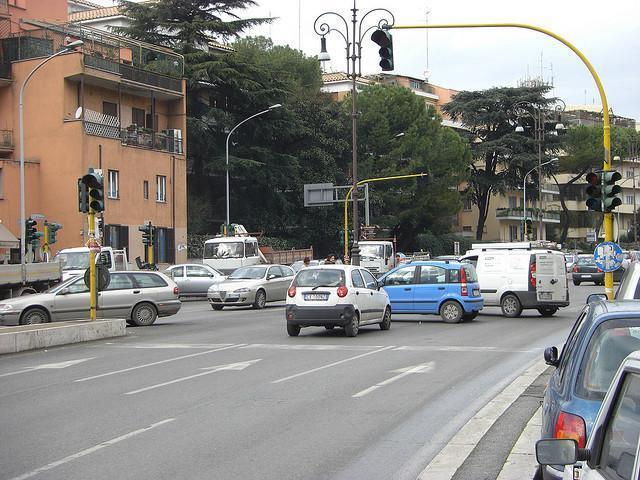How many cars can be seen?
Give a very brief answer. 6. 